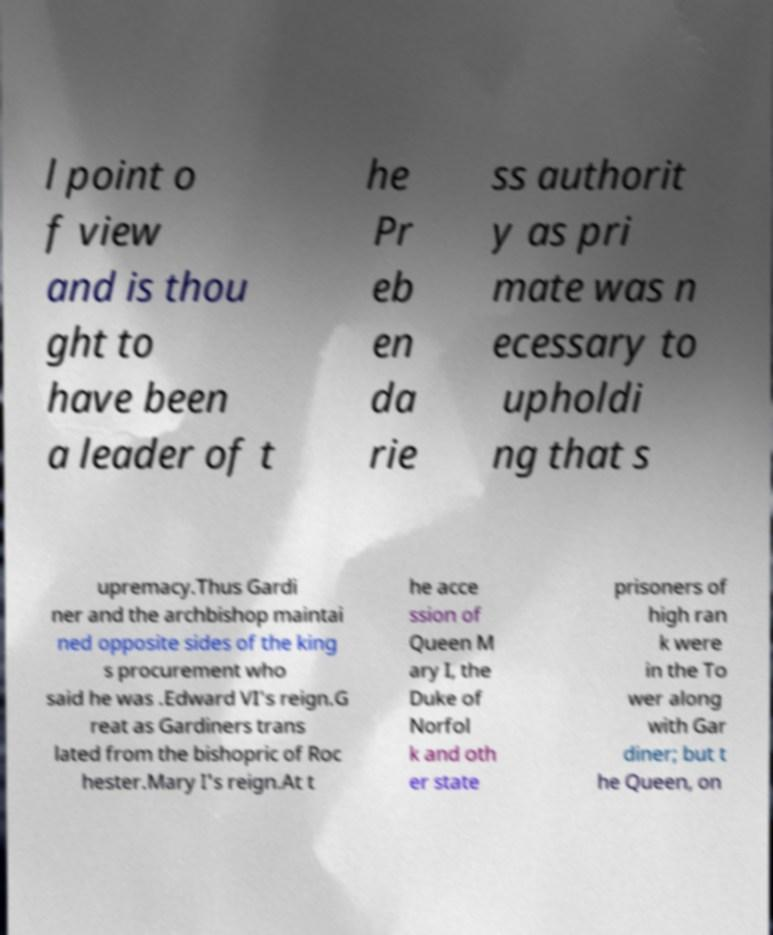Could you extract and type out the text from this image? l point o f view and is thou ght to have been a leader of t he Pr eb en da rie ss authorit y as pri mate was n ecessary to upholdi ng that s upremacy.Thus Gardi ner and the archbishop maintai ned opposite sides of the king s procurement who said he was .Edward VI's reign.G reat as Gardiners trans lated from the bishopric of Roc hester.Mary I's reign.At t he acce ssion of Queen M ary I, the Duke of Norfol k and oth er state prisoners of high ran k were in the To wer along with Gar diner; but t he Queen, on 